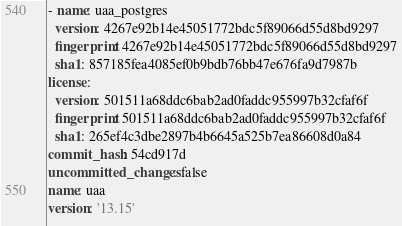Convert code to text. <code><loc_0><loc_0><loc_500><loc_500><_YAML_>- name: uaa_postgres
  version: 4267e92b14e45051772bdc5f89066d55d8bd9297
  fingerprint: 4267e92b14e45051772bdc5f89066d55d8bd9297
  sha1: 857185fea4085ef0b9bdb76bb47e676fa9d7987b
license:
  version: 501511a68ddc6bab2ad0faddc955997b32cfaf6f
  fingerprint: 501511a68ddc6bab2ad0faddc955997b32cfaf6f
  sha1: 265ef4c3dbe2897b4b6645a525b7ea86608d0a84
commit_hash: 54cd917d
uncommitted_changes: false
name: uaa
version: '13.15'
</code> 